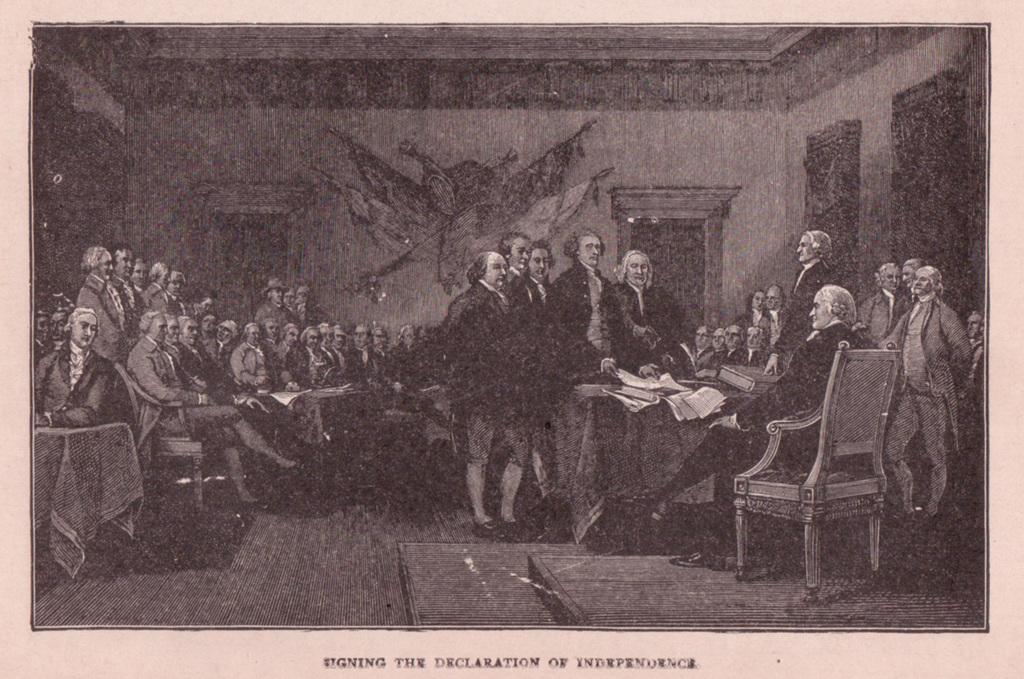In one or two sentences, can you explain what this image depicts? This is a black and white photo and here we can see many people and there are some papers, books and some other objects are on the tables and we can see chairs and clothes and there is some text. 